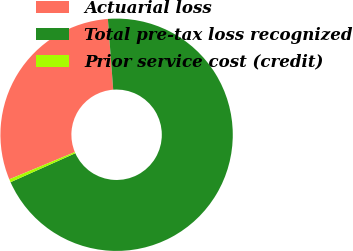<chart> <loc_0><loc_0><loc_500><loc_500><pie_chart><fcel>Actuarial loss<fcel>Total pre-tax loss recognized<fcel>Prior service cost (credit)<nl><fcel>30.07%<fcel>69.5%<fcel>0.43%<nl></chart> 